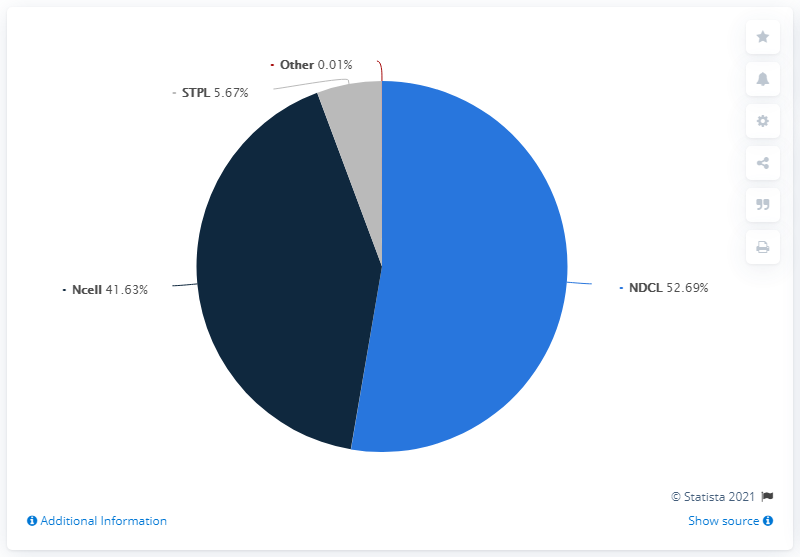List a handful of essential elements in this visual. The average of the first highest value and the third highest value in the pie chart is approximately 29.18. The use of light blue color in the text "NDCL.." indicates that it is a reference to a specific meaning or information related to the NDCL. 